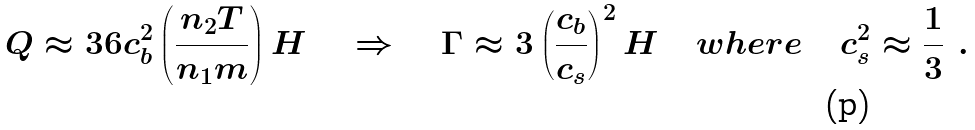Convert formula to latex. <formula><loc_0><loc_0><loc_500><loc_500>Q \approx 3 6 c _ { b } ^ { 2 } \left ( \frac { n _ { 2 } T } { n _ { 1 } m } \right ) H \quad \Rightarrow \quad \Gamma \approx 3 \left ( \frac { c _ { b } } { c _ { s } } \right ) ^ { 2 } H \quad w h e r e \quad c _ { s } ^ { 2 } \approx \frac { 1 } { 3 } \ .</formula> 